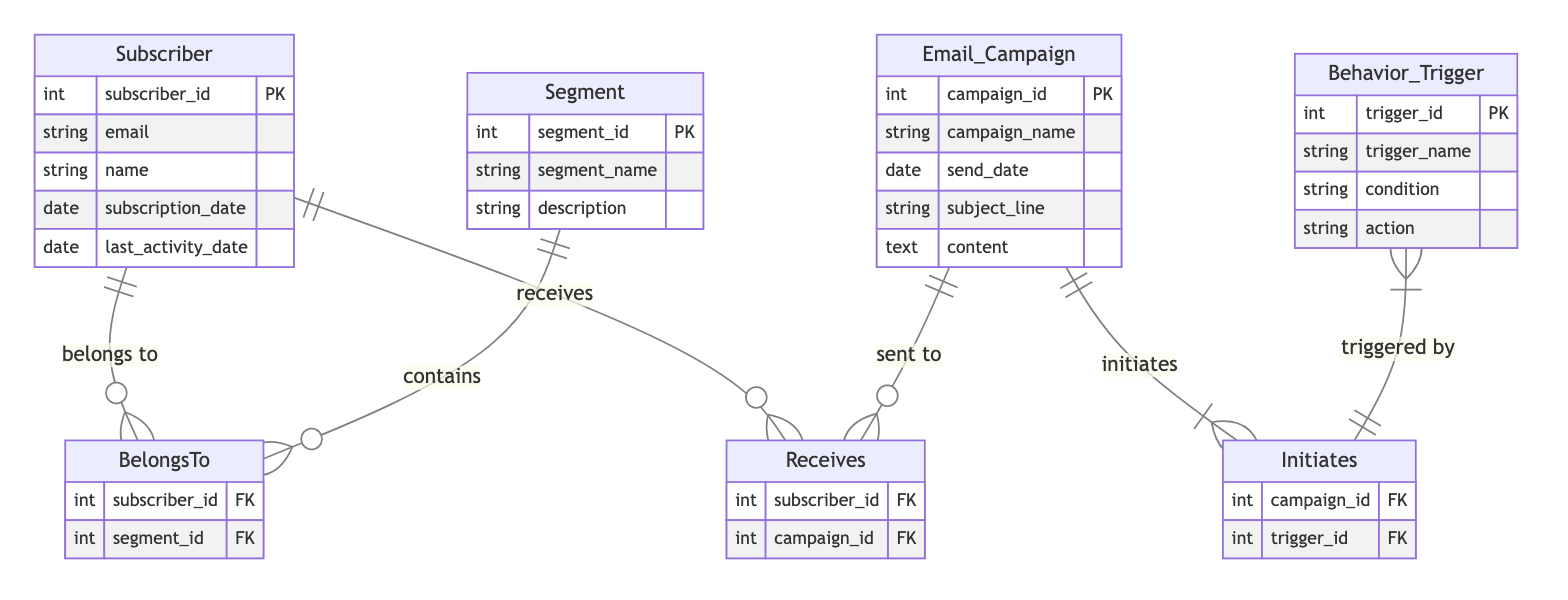What are the attributes of the Subscriber entity? The Subscriber entity has the following attributes: subscriber_id, email, name, subscription_date, last_activity_date. By referring to the diagram, one can identify these attributes listed under the Subscriber entity.
Answer: subscriber_id, email, name, subscription_date, last_activity_date How many entities are in the diagram? The diagram includes four entities: Subscriber, Segment, Email Campaign, and Behavior Trigger. The counting involves simply listing out the entities depicted in the diagram.
Answer: 4 Which entity receives Email Campaigns? The entity that receives Email Campaigns is the Subscriber. The diagram indicates that the Subscriber is connected to the Email Campaign entity through the "Receives" relationship.
Answer: Subscriber How many attributes does the Email Campaign entity have? The Email Campaign entity has five attributes: campaign_id, campaign_name, send_date, subject_line, and content. This count is determined by listing the attributes under the Email Campaign entity.
Answer: 5 What is the action associated with Behavior Triggers? The action associated with Behavior Triggers is determined by the attribute "action" in the Behavior Trigger entity. The relationship "Initiates" shows that these triggers can initiate actions linked to email campaigns.
Answer: action Which entity can belong to multiple segments? The entity that can belong to multiple segments is the Subscriber. This is because of the many-to-many relationship established in the diagram between Subscriber and Segment.
Answer: Subscriber What connects Behavior Trigger to Email Campaign? The connection between Behavior Trigger and Email Campaign is made through the "Initiates" relationship. This indicates that an Email Campaign can initiate one or more behavior triggers.
Answer: Initiates How many relationships are present in the diagram? There are three relationships present in the diagram: BelongsTo, Receives, and Initiates. These relationships can be counted directly from the relationships depicted in the diagram.
Answer: 3 